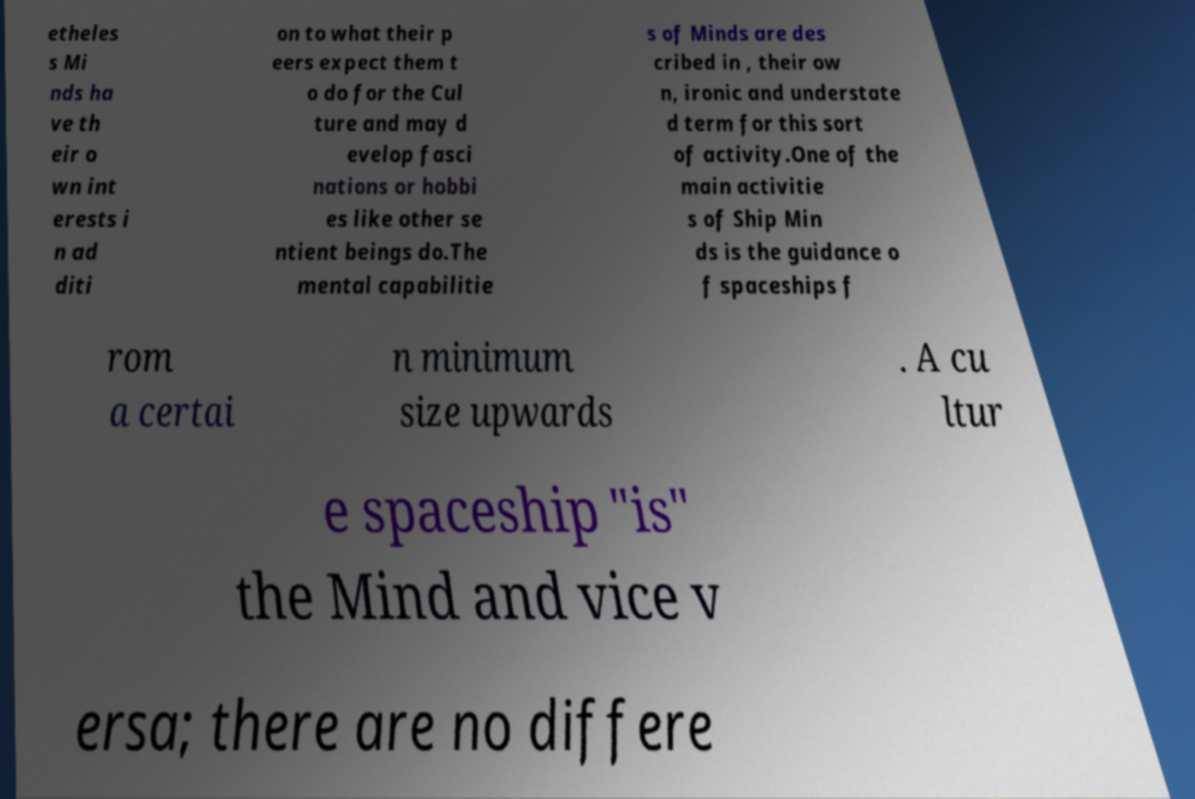What messages or text are displayed in this image? I need them in a readable, typed format. etheles s Mi nds ha ve th eir o wn int erests i n ad diti on to what their p eers expect them t o do for the Cul ture and may d evelop fasci nations or hobbi es like other se ntient beings do.The mental capabilitie s of Minds are des cribed in , their ow n, ironic and understate d term for this sort of activity.One of the main activitie s of Ship Min ds is the guidance o f spaceships f rom a certai n minimum size upwards . A cu ltur e spaceship "is" the Mind and vice v ersa; there are no differe 